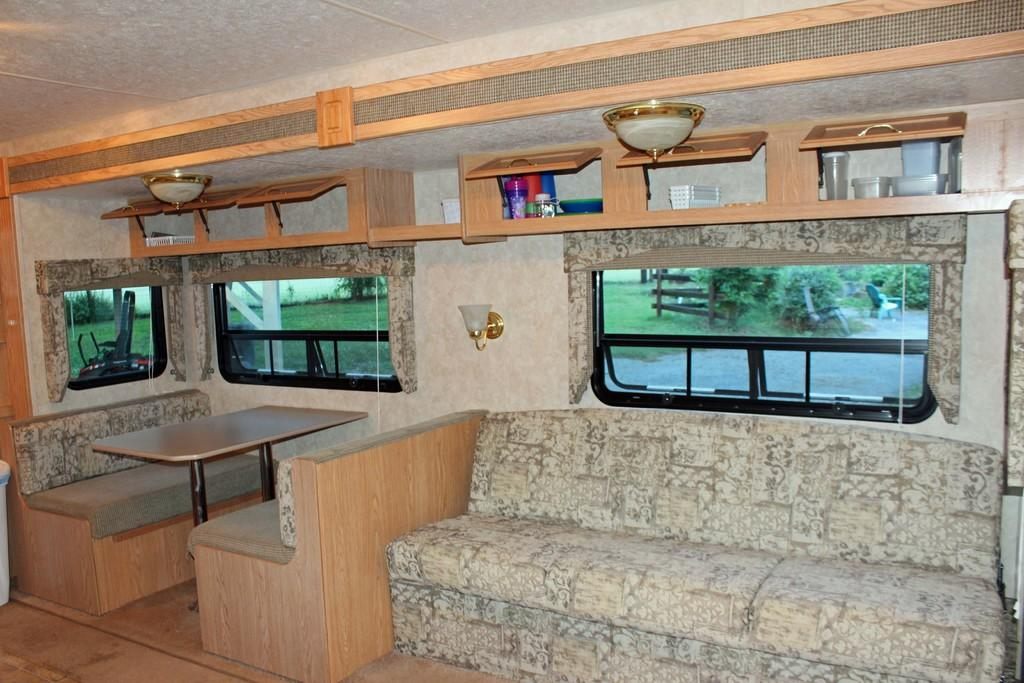What type of furniture is present in the image? There is a sofa set in the image. What other piece of furniture can be seen in the image? There is a table in the image. What is visible through the window in the image? Trees are visible in the image. What part of the building is visible in the image? There is a roof in the image. What shape is the sofa set in the image? The shape of the sofa set cannot be determined from the image, as it only provides information about the presence of a sofa set, table, window, trees, and roof. Can you see any clouds in the image? There is no mention of clouds in the provided facts, so it cannot be determined if they are present in the image. 